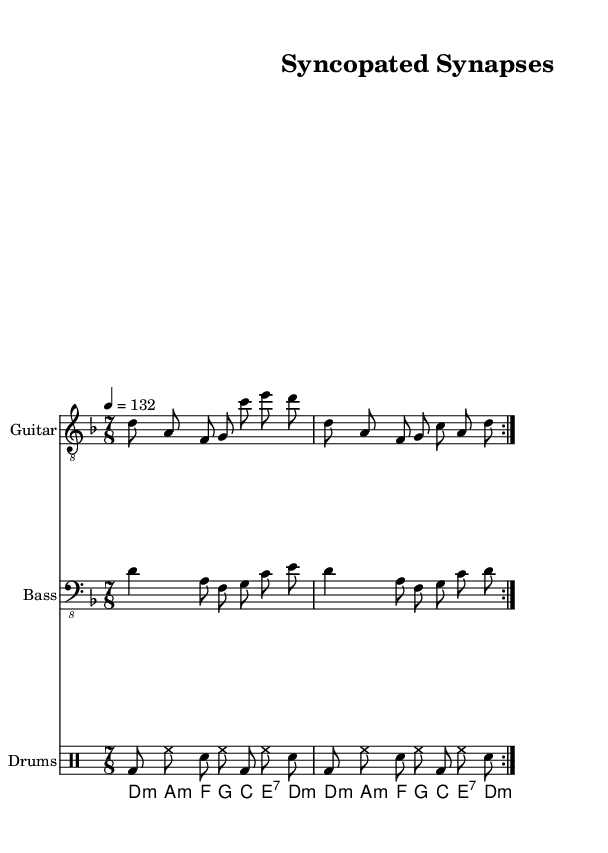What is the key signature of this music? The key signature is D minor, which has one flat (B flat).
Answer: D minor What is the time signature of this music? The time signature is indicated at the beginning of the score as 7/8.
Answer: 7/8 What is the tempo marking of this piece? The tempo marking indicates a speed of quarter note = 132 beats per minute.
Answer: 132 How many measures are in the main riff for the electric guitar? The main riff is repeated twice, and it contains 2 measures each time, resulting in a total of 4 measures.
Answer: 4 What type of chord progression is used in the synth part? The synth part features a progression consisting of minor and major chords based on the key of D minor.
Answer: Minor and major How does the drum pattern contribute to the overall feel of the piece? The drum pattern utilizes a mixture of bass and snare hits with hi-hats, creating a driving rhythm characteristic of progressive metal.
Answer: Driving rhythm What is the significance of the 7/8 time signature in metal music? The 7/8 time signature adds complexity and an offbeat feel to the music, typical for progressive metal to create a unique rhythmic texture.
Answer: Complexity 